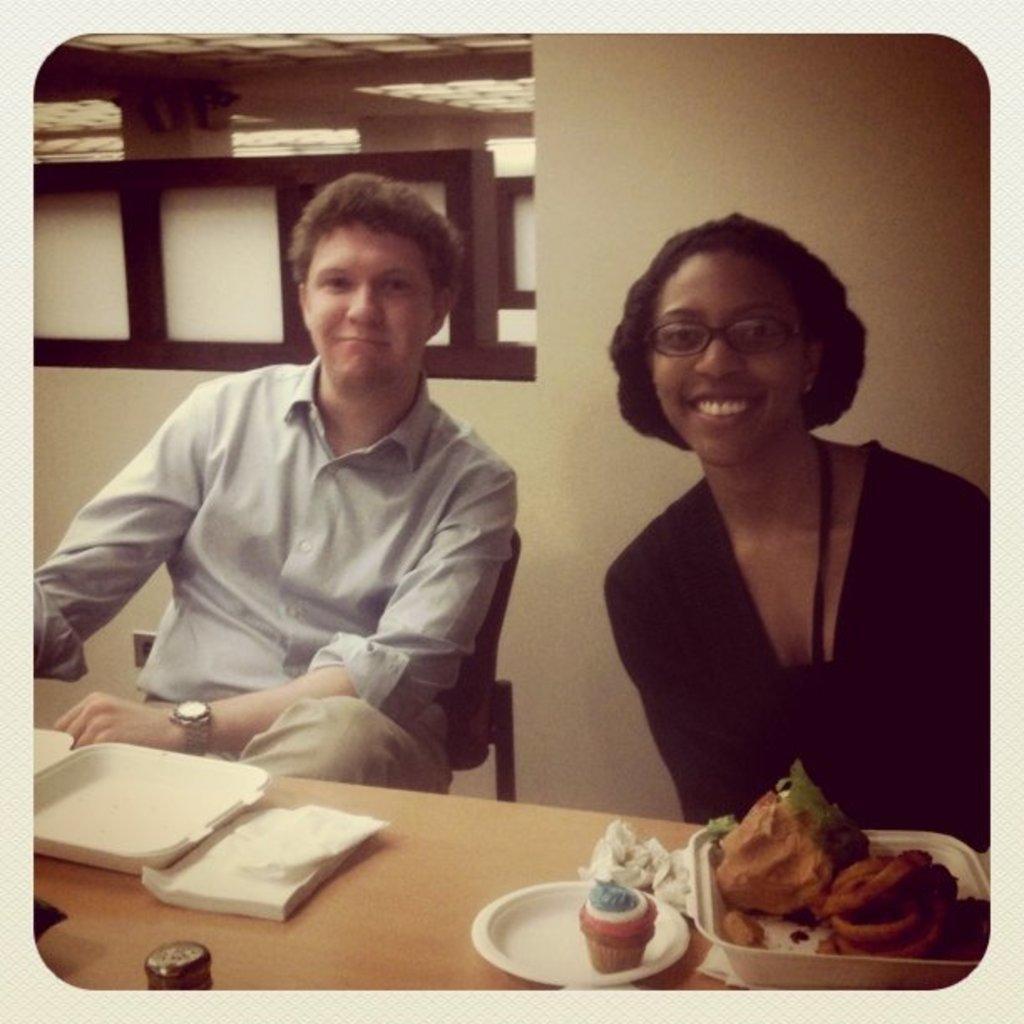Please provide a concise description of this image. In this image I can see a man wearing white shirt and cream pant and a woman wearing black color dress are sitting in front of a brown colored table. On the table I can see a plate with cupcake on it, a tray with brown colored food item in it and few other white colored objects. In the background I can see the wall, the ceiling and few lights to the ceiling. 